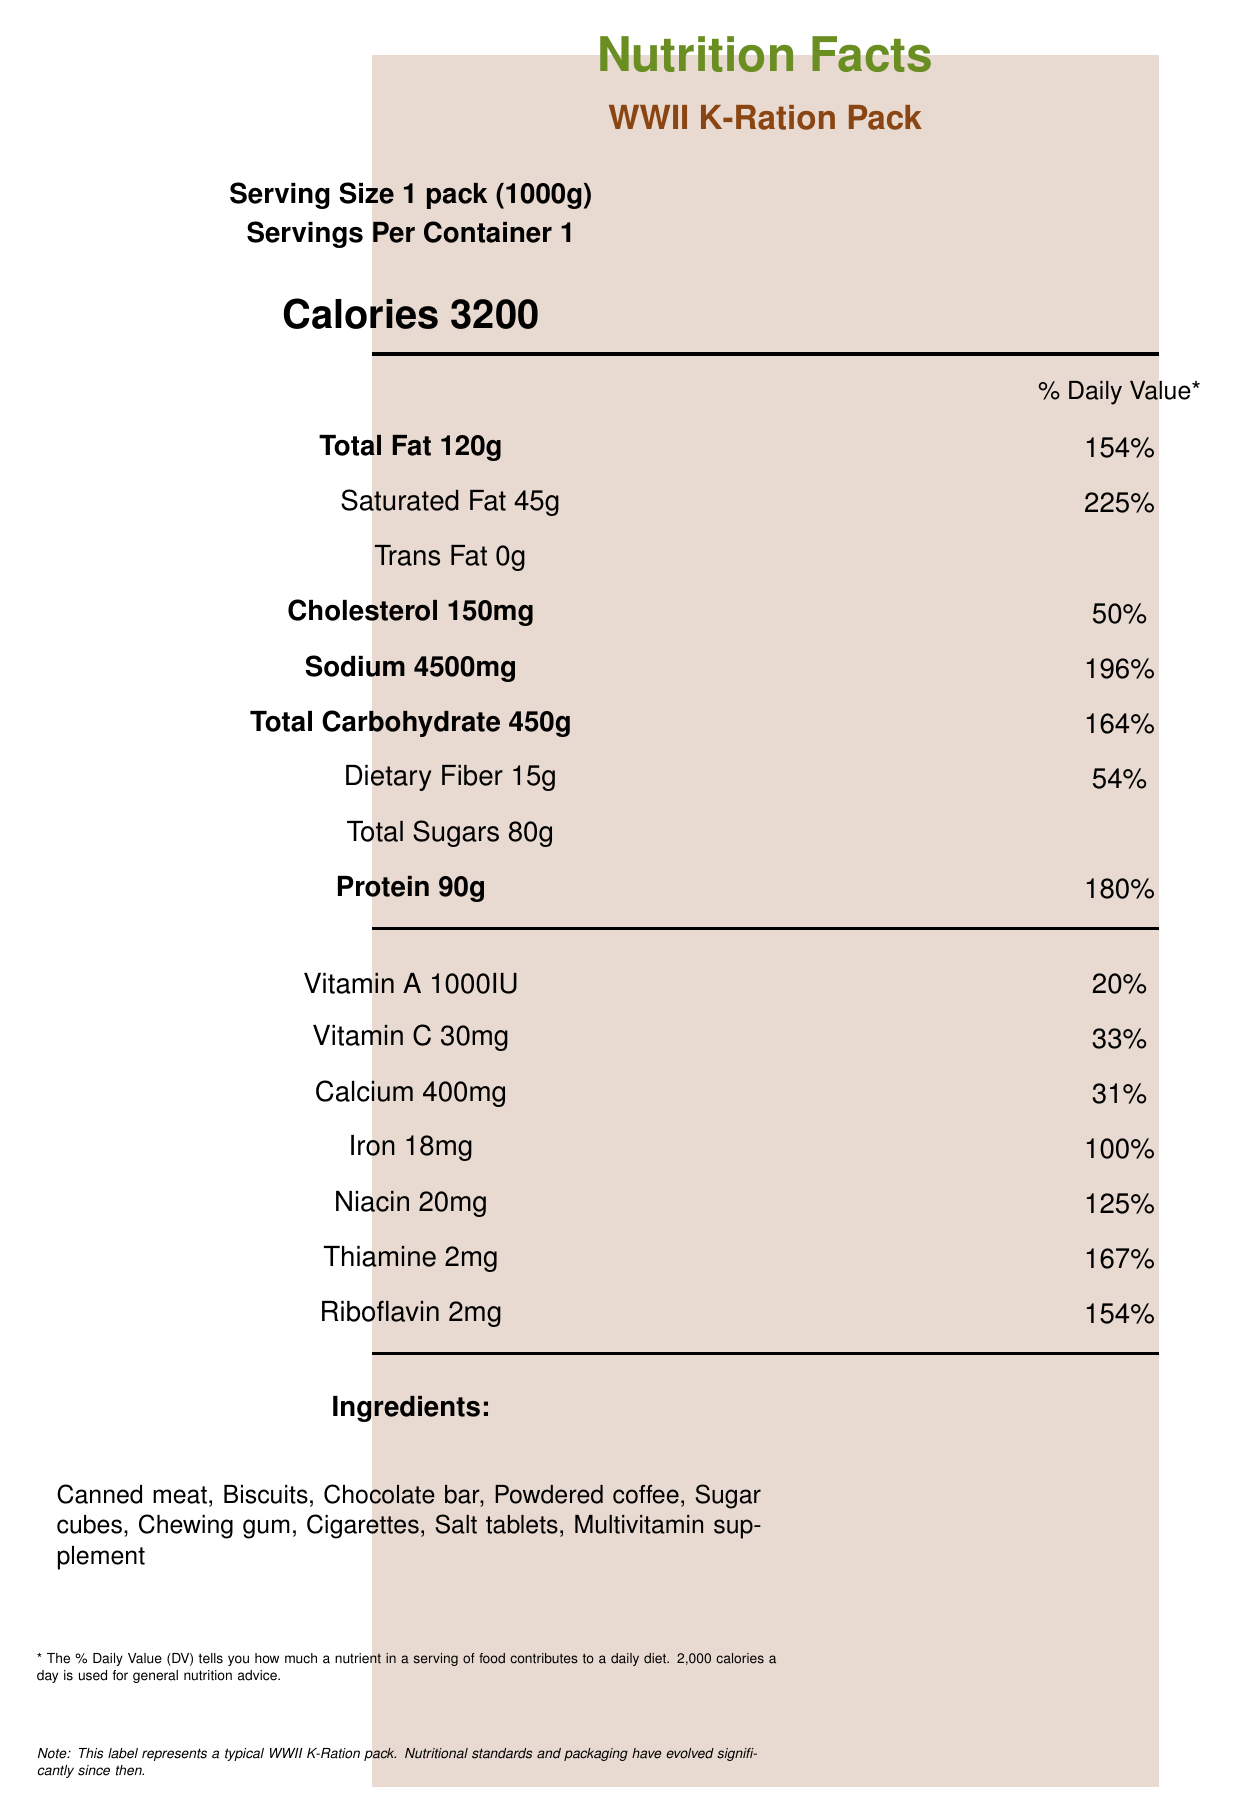how many calories are in a WWII K-Ration Pack? The label states "Calories 3200" in the "Calorie information" section.
Answer: 3200 What is the % Daily Value for total fat in the K-Ration Pack? The label specifies "Total Fat 120g," with a % Daily Value of 154%.
Answer: 154% What are the three main sources of food in the K-Ration Pack? The "Ingredients" section of the label lists these items.
Answer: Canned meat, Biscuits, Chocolate bar What is the amount of dietary fiber in the K-Ration Pack? The label indicates "Dietary Fiber 15g" in the "Nutrient information" section.
Answer: 15g How much sodium does the K-Ration Pack contain? The label shows "Sodium 4500mg" in the "Nutrient information" section.
Answer: 4500mg What was the primary purpose of developing the K-Ration Pack? A. To create a luxury meal for soldiers B. To provide nutrition in combat situations C. To promote local agriculture D. To introduce new food products The "historical context" section specifies that the purpose was "To provide adequate nutrition in combat situations."
Answer: B Which of the following is NOT an ingredient in the K-Ration Pack? A. Chewing gum B. Fresh fruit C. Powdered coffee D. Sugar cubes The "Ingredients" section does not list fresh fruit as an ingredient.
Answer: B Does the K-Ration Pack contain any trans fat? The label lists "Trans Fat 0g" in the "Nutrient information" section.
Answer: No Summarize the main concerns addressed by the nutritional information of the K-Ration Pack. The label outlines the nutritional content and highlights that while the high calorie content and vitamin fortification were suitable for soldiers' needs, the high levels of fat, sodium, and other nutritional deficiencies presented challenges.
Answer: The K-Ration Pack provides high calories and essential vitamins and minerals to support soldiers' intense physical activities. However, it also has excessive saturated fats, high sodium levels, and limited dietary fiber, and includes non-nutritional items like cigarettes. What are the long-term impacts of the K-Ration Pack outlined in the document? The "historical context" section mentions this in the "impact" subsection.
Answer: Influenced post-war food technology and nutrition science How does the sodium content in the K-Ration Pack compare to modern dietary recommendations? The label indicates "Sodium 4500mg," giving a % Daily Value of 196%, which is almost double the recommended daily intake.
Answer: High Who developed the K-Ration Pack? The "historical context" section states it was developed by the "Quartermaster Corps in 1941."
Answer: Quartermaster Corps What does the document state as a limitation in the K-Ration Pack regarding vitamins? The "nutritional concerns" section mentions this as a limitation.
Answer: Limited fresh fruits and vegetables, leading to potential vitamin deficiencies Name a non-nutritional item included in the K-Ration Pack. The "Ingredients" section lists "Cigarettes" among the items.
Answer: Cigarettes What year was the K-Ration Pack developed? The "development" part of the "historical context" section states it was developed in 1941.
Answer: 1941 How does the K-Ration Pack's preparation potentially affect nutrient preservation? The document does not provide specific details on how preparation affects nutrient preservation.
Answer: Cannot be determined How often should a soldier consume a K-Ration Pack to meet their daily caloric needs? With "Calories 3200" and assuming a daily caloric need of around 3200 for active soldiers, one pack is suitable.
Answer: Once per day 